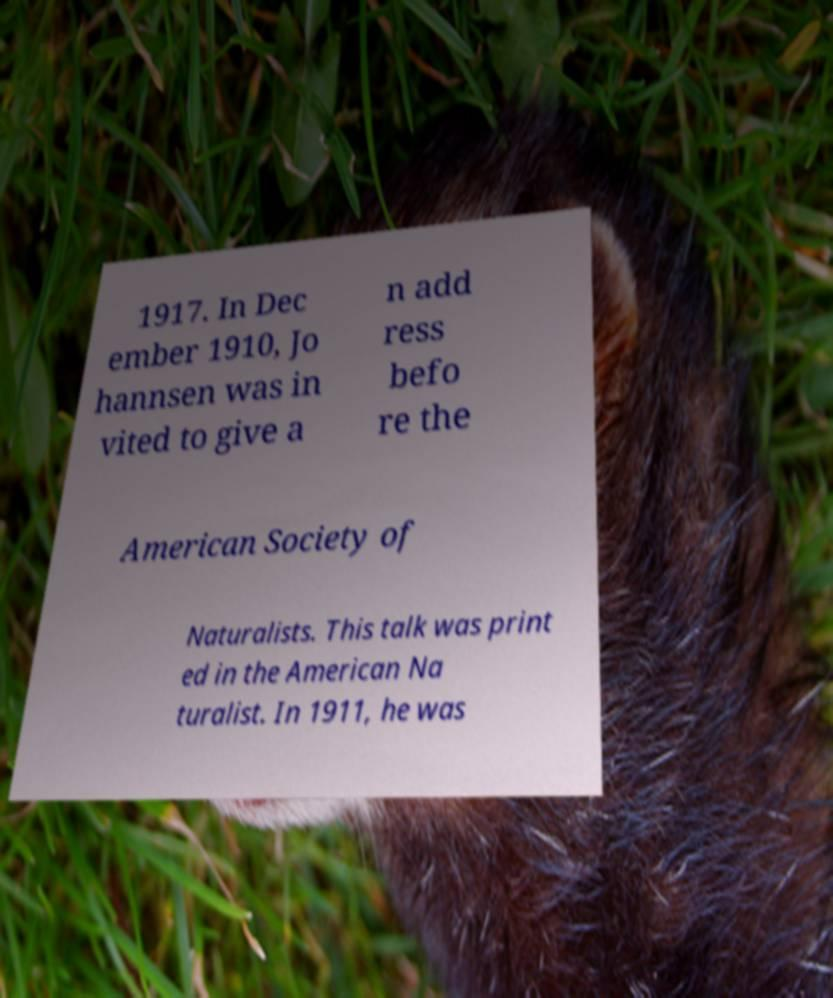There's text embedded in this image that I need extracted. Can you transcribe it verbatim? 1917. In Dec ember 1910, Jo hannsen was in vited to give a n add ress befo re the American Society of Naturalists. This talk was print ed in the American Na turalist. In 1911, he was 